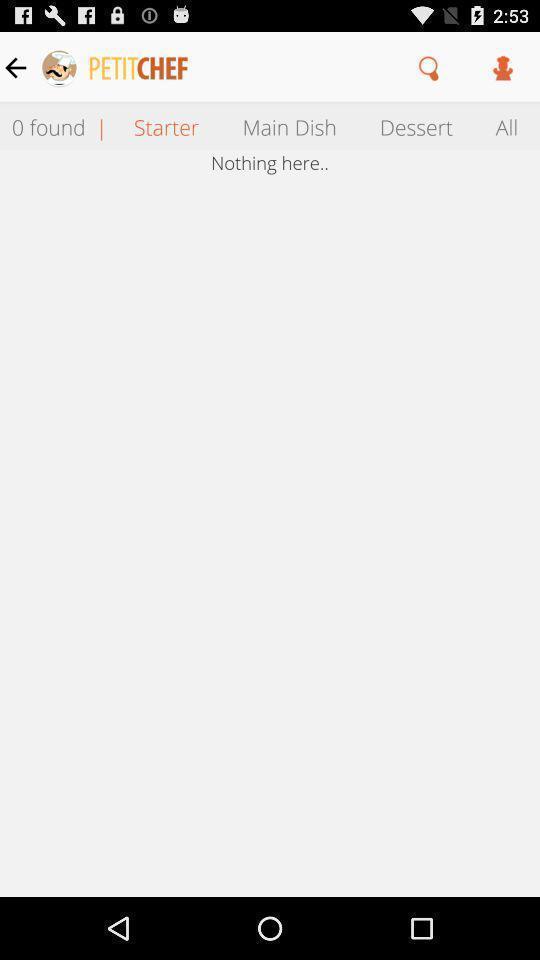Provide a description of this screenshot. Screen shows about a starter. 